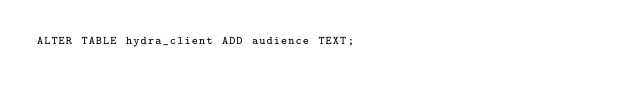Convert code to text. <code><loc_0><loc_0><loc_500><loc_500><_SQL_>ALTER TABLE hydra_client ADD audience TEXT;
</code> 